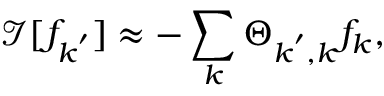<formula> <loc_0><loc_0><loc_500><loc_500>\mathcal { I } [ f _ { k ^ { \prime } } ] \approx - \sum _ { k } \Theta _ { k ^ { \prime } , k } f _ { k } ,</formula> 